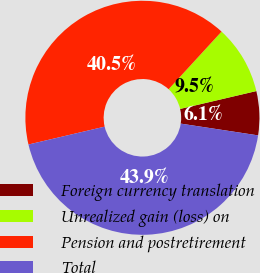Convert chart to OTSL. <chart><loc_0><loc_0><loc_500><loc_500><pie_chart><fcel>Foreign currency translation<fcel>Unrealized gain (loss) on<fcel>Pension and postretirement<fcel>Total<nl><fcel>6.07%<fcel>9.51%<fcel>40.49%<fcel>43.93%<nl></chart> 